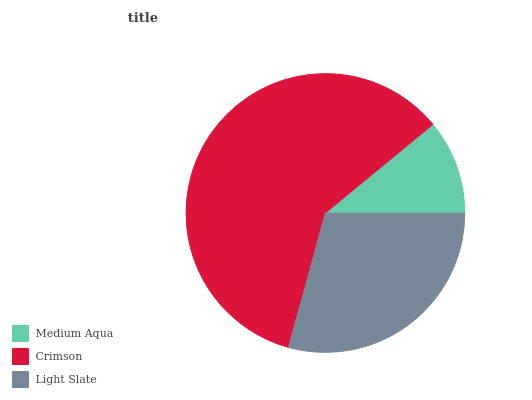Is Medium Aqua the minimum?
Answer yes or no. Yes. Is Crimson the maximum?
Answer yes or no. Yes. Is Light Slate the minimum?
Answer yes or no. No. Is Light Slate the maximum?
Answer yes or no. No. Is Crimson greater than Light Slate?
Answer yes or no. Yes. Is Light Slate less than Crimson?
Answer yes or no. Yes. Is Light Slate greater than Crimson?
Answer yes or no. No. Is Crimson less than Light Slate?
Answer yes or no. No. Is Light Slate the high median?
Answer yes or no. Yes. Is Light Slate the low median?
Answer yes or no. Yes. Is Crimson the high median?
Answer yes or no. No. Is Crimson the low median?
Answer yes or no. No. 